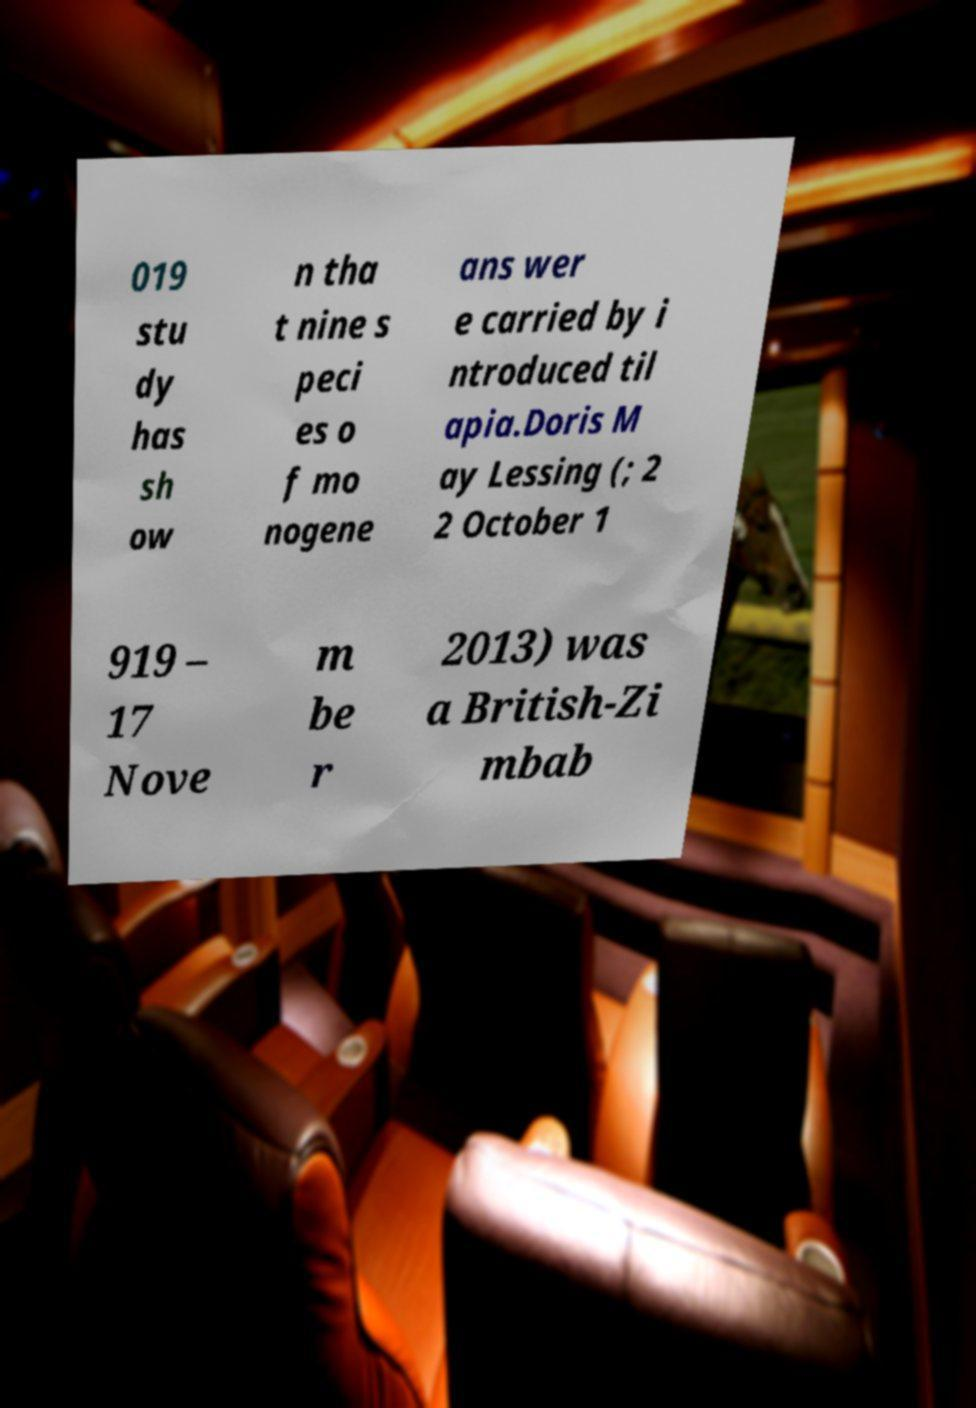I need the written content from this picture converted into text. Can you do that? 019 stu dy has sh ow n tha t nine s peci es o f mo nogene ans wer e carried by i ntroduced til apia.Doris M ay Lessing (; 2 2 October 1 919 – 17 Nove m be r 2013) was a British-Zi mbab 